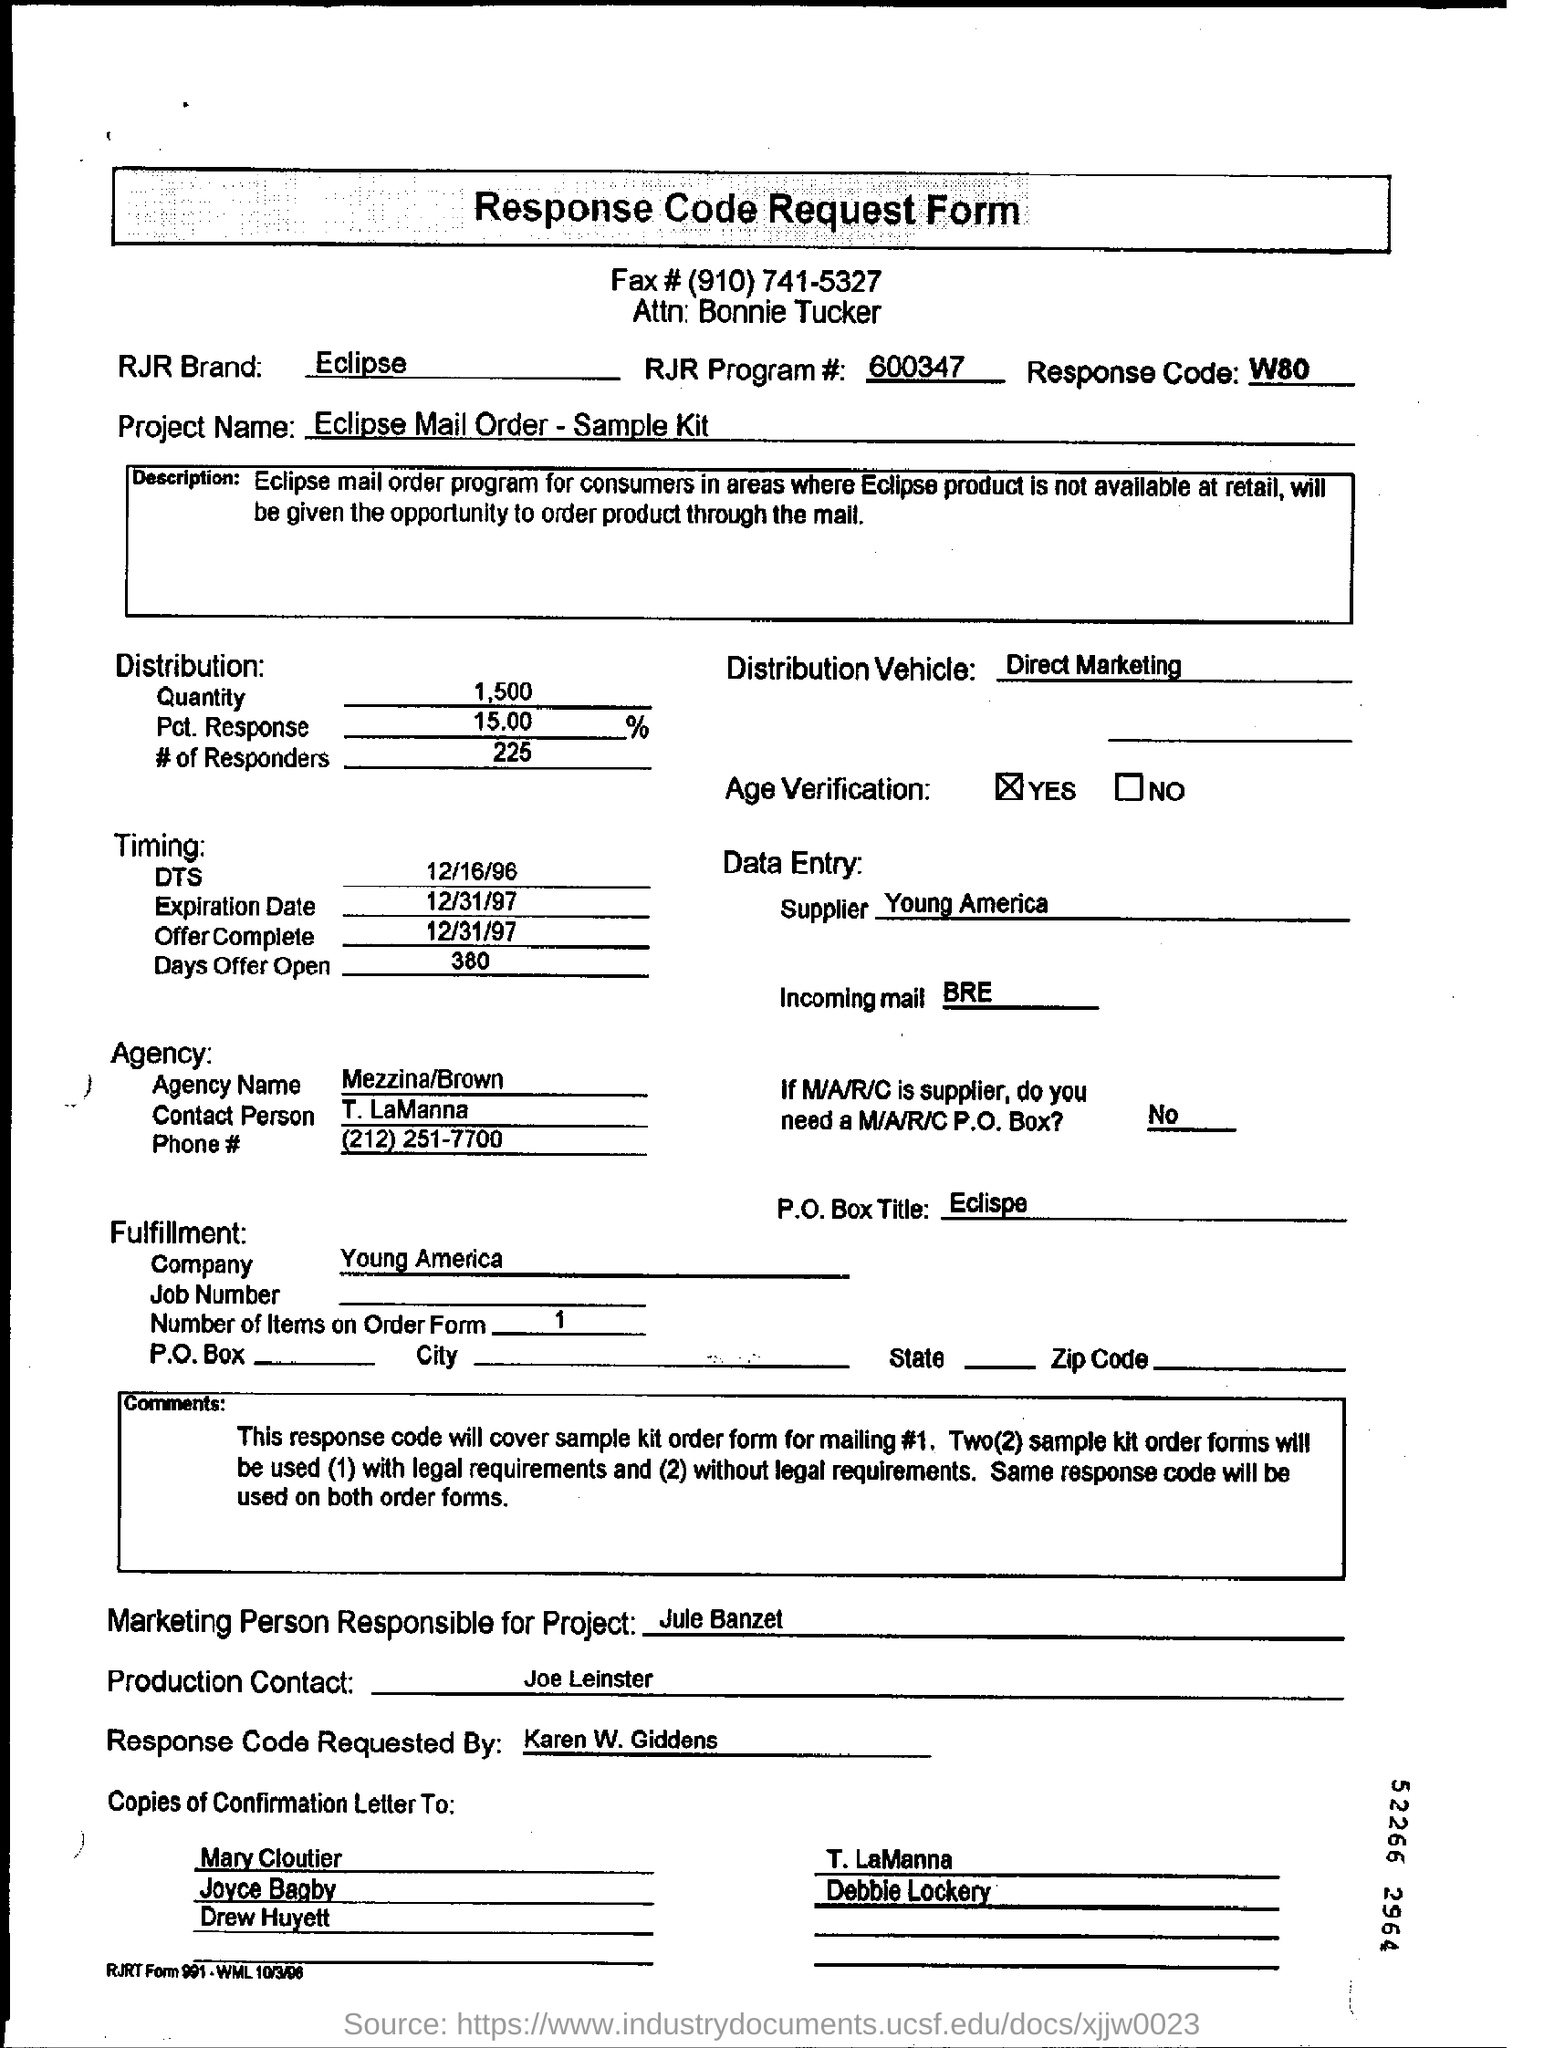What is the RJR Brand mentioned?
Offer a terse response. Eclipse. What is the project name mentioned?
Provide a succinct answer. Eclipse Mail Order-Sample Kit. Who is the Supplier mentioned in the Data Entry?
Offer a very short reply. Young America. 